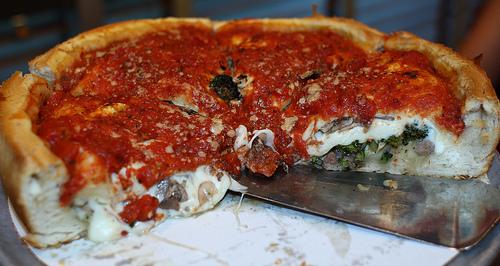In what kind of dish is the pizza served and what is its size? The pizza is served in a deep dish, with a width of 495 and height of 495. How many distinct objects are present in the image, and which one has the largest size? There are 31 distinct objects in the image, and the half pepperoni pizza is the largest with a width of 492 and height of 492. What is the primary object in the image being used for, and what are its characteristics? A silver spatula is being used to grab a slice of pizza, and it has a width of 271 and height of 271. What type of pizza is depicted in the image and what are some of its unique features? A half pepperoni and spinach deep-dish pizza with thick crust, red sauce, cheese, mushrooms, and broccoli as toppings and a width of 492 and height of 492. Describe the sentiment conveyed by the image. The image conveys a sense of enjoyment and satisfaction in indulging in a delicious deep-dish pizza. Evaluate the quality of the image based on clarity and detail. The image is of high quality and clarity, with various objects and their respective sizes and positions well-detailed and specified. 